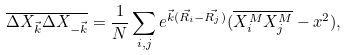Convert formula to latex. <formula><loc_0><loc_0><loc_500><loc_500>\overline { \Delta X _ { \vec { k } } \Delta X _ { - \vec { k } } } = \frac { 1 } { N } \sum _ { i , j } e ^ { \vec { k } ( \vec { R _ { i } } - \vec { R _ { j } } ) } ( \overline { X ^ { M } _ { i } X ^ { M } _ { j } } - x ^ { 2 } ) ,</formula> 